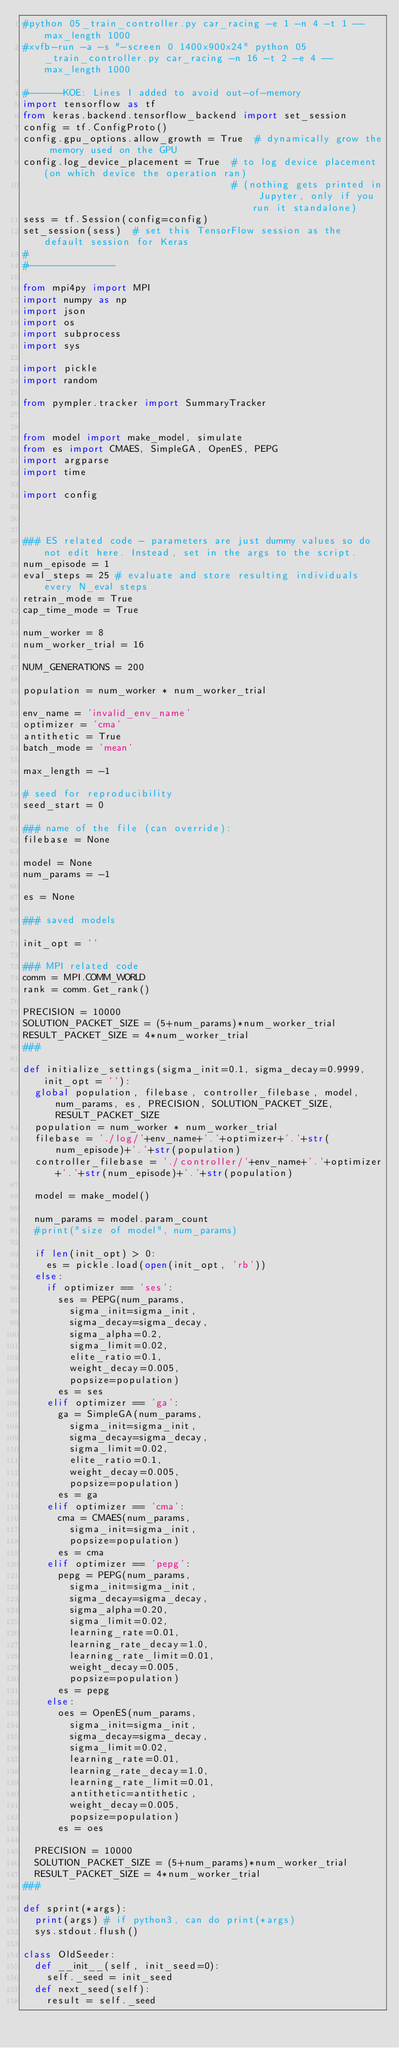Convert code to text. <code><loc_0><loc_0><loc_500><loc_500><_Python_>#python 05_train_controller.py car_racing -e 1 -n 4 -t 1 --max_length 1000
#xvfb-run -a -s "-screen 0 1400x900x24" python 05_train_controller.py car_racing -n 16 -t 2 -e 4 --max_length 1000

#------KOE: Lines I added to avoid out-of-memory
import tensorflow as tf
from keras.backend.tensorflow_backend import set_session
config = tf.ConfigProto()
config.gpu_options.allow_growth = True  # dynamically grow the memory used on the GPU
config.log_device_placement = True  # to log device placement (on which device the operation ran)
                                    # (nothing gets printed in Jupyter, only if you run it standalone)
sess = tf.Session(config=config)
set_session(sess)  # set this TensorFlow session as the default session for Keras
#
#---------------

from mpi4py import MPI
import numpy as np
import json
import os
import subprocess
import sys

import pickle
import random

from pympler.tracker import SummaryTracker


from model import make_model, simulate
from es import CMAES, SimpleGA, OpenES, PEPG
import argparse
import time

import config



### ES related code - parameters are just dummy values so do not edit here. Instead, set in the args to the script.
num_episode = 1
eval_steps = 25 # evaluate and store resulting individuals every N_eval steps
retrain_mode = True
cap_time_mode = True

num_worker = 8
num_worker_trial = 16

NUM_GENERATIONS = 200

population = num_worker * num_worker_trial

env_name = 'invalid_env_name'
optimizer = 'cma'
antithetic = True
batch_mode = 'mean'

max_length = -1

# seed for reproducibility
seed_start = 0

### name of the file (can override):
filebase = None

model = None
num_params = -1

es = None

### saved models

init_opt = ''

### MPI related code
comm = MPI.COMM_WORLD
rank = comm.Get_rank()

PRECISION = 10000
SOLUTION_PACKET_SIZE = (5+num_params)*num_worker_trial
RESULT_PACKET_SIZE = 4*num_worker_trial
###

def initialize_settings(sigma_init=0.1, sigma_decay=0.9999, init_opt = ''):
  global population, filebase, controller_filebase, model, num_params, es, PRECISION, SOLUTION_PACKET_SIZE, RESULT_PACKET_SIZE
  population = num_worker * num_worker_trial
  filebase = './log/'+env_name+'.'+optimizer+'.'+str(num_episode)+'.'+str(population)
  controller_filebase = './controller/'+env_name+'.'+optimizer+'.'+str(num_episode)+'.'+str(population)

  model = make_model()

  num_params = model.param_count
  #print("size of model", num_params)

  if len(init_opt) > 0:
    es = pickle.load(open(init_opt, 'rb'))  
  else:
    if optimizer == 'ses':
      ses = PEPG(num_params,
        sigma_init=sigma_init,
        sigma_decay=sigma_decay,
        sigma_alpha=0.2,
        sigma_limit=0.02,
        elite_ratio=0.1,
        weight_decay=0.005,
        popsize=population)
      es = ses
    elif optimizer == 'ga':
      ga = SimpleGA(num_params,
        sigma_init=sigma_init,
        sigma_decay=sigma_decay,
        sigma_limit=0.02,
        elite_ratio=0.1,
        weight_decay=0.005,
        popsize=population)
      es = ga
    elif optimizer == 'cma':
      cma = CMAES(num_params,
        sigma_init=sigma_init,
        popsize=population)
      es = cma
    elif optimizer == 'pepg':
      pepg = PEPG(num_params,
        sigma_init=sigma_init,
        sigma_decay=sigma_decay,
        sigma_alpha=0.20,
        sigma_limit=0.02,
        learning_rate=0.01,
        learning_rate_decay=1.0,
        learning_rate_limit=0.01,
        weight_decay=0.005,
        popsize=population)
      es = pepg
    else:
      oes = OpenES(num_params,
        sigma_init=sigma_init,
        sigma_decay=sigma_decay,
        sigma_limit=0.02,
        learning_rate=0.01,
        learning_rate_decay=1.0,
        learning_rate_limit=0.01,
        antithetic=antithetic,
        weight_decay=0.005,
        popsize=population)
      es = oes

  PRECISION = 10000
  SOLUTION_PACKET_SIZE = (5+num_params)*num_worker_trial
  RESULT_PACKET_SIZE = 4*num_worker_trial
###

def sprint(*args):
  print(args) # if python3, can do print(*args)
  sys.stdout.flush()

class OldSeeder:
  def __init__(self, init_seed=0):
    self._seed = init_seed
  def next_seed(self):
    result = self._seed</code> 